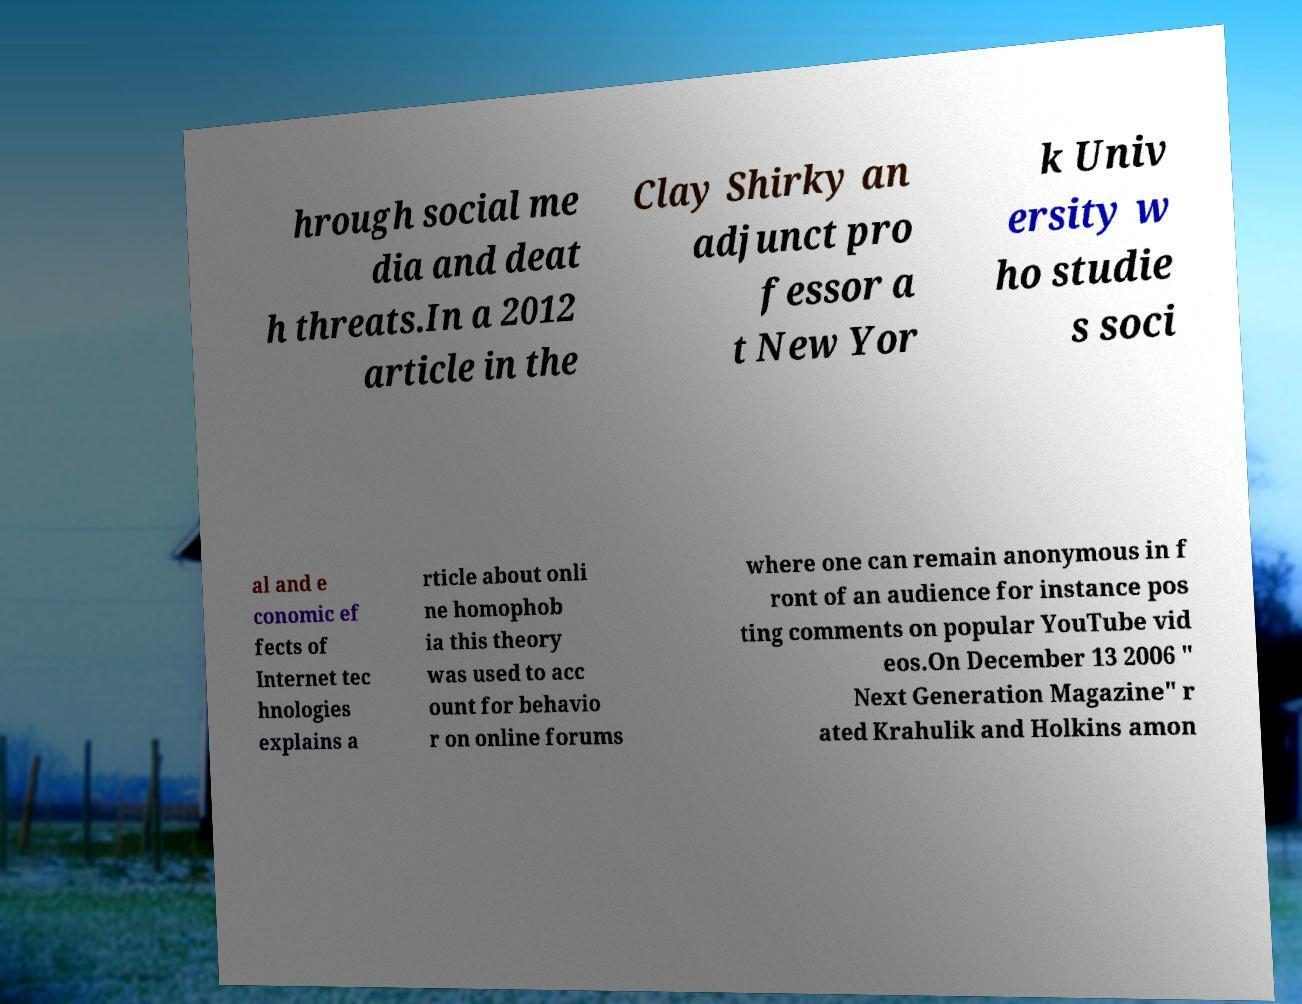Could you assist in decoding the text presented in this image and type it out clearly? hrough social me dia and deat h threats.In a 2012 article in the Clay Shirky an adjunct pro fessor a t New Yor k Univ ersity w ho studie s soci al and e conomic ef fects of Internet tec hnologies explains a rticle about onli ne homophob ia this theory was used to acc ount for behavio r on online forums where one can remain anonymous in f ront of an audience for instance pos ting comments on popular YouTube vid eos.On December 13 2006 " Next Generation Magazine" r ated Krahulik and Holkins amon 